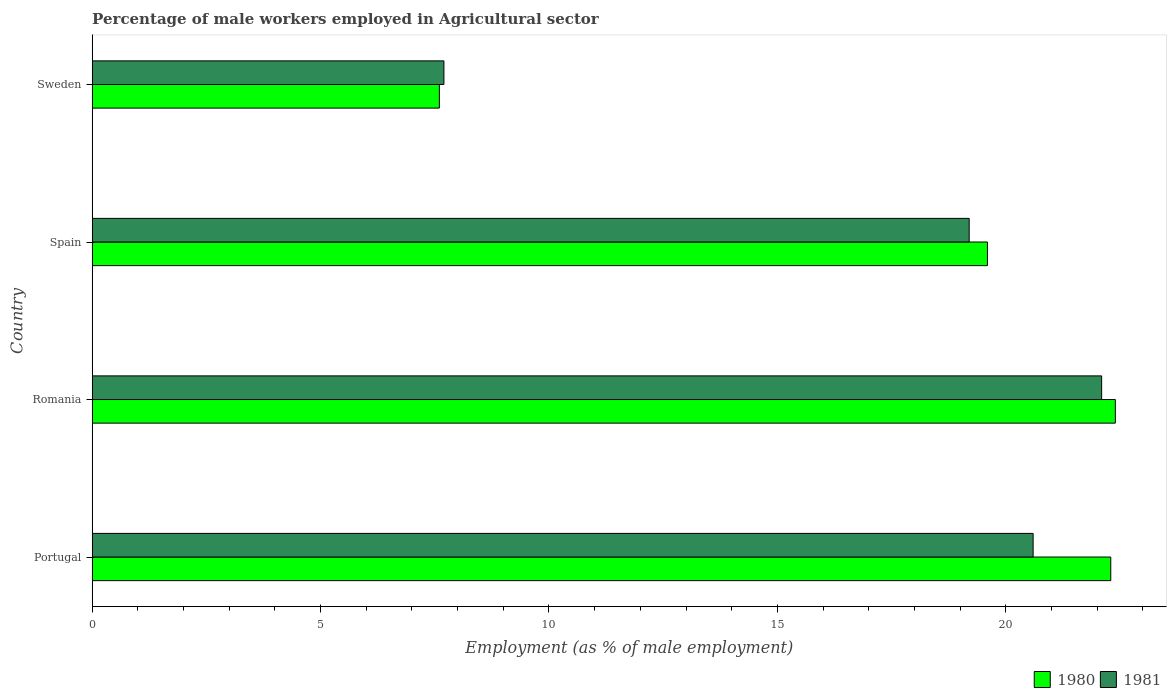How many different coloured bars are there?
Your answer should be very brief. 2. How many bars are there on the 2nd tick from the top?
Your response must be concise. 2. How many bars are there on the 3rd tick from the bottom?
Offer a very short reply. 2. What is the percentage of male workers employed in Agricultural sector in 1980 in Spain?
Your answer should be compact. 19.6. Across all countries, what is the maximum percentage of male workers employed in Agricultural sector in 1980?
Provide a succinct answer. 22.4. Across all countries, what is the minimum percentage of male workers employed in Agricultural sector in 1980?
Keep it short and to the point. 7.6. In which country was the percentage of male workers employed in Agricultural sector in 1980 maximum?
Provide a short and direct response. Romania. In which country was the percentage of male workers employed in Agricultural sector in 1981 minimum?
Make the answer very short. Sweden. What is the total percentage of male workers employed in Agricultural sector in 1981 in the graph?
Give a very brief answer. 69.6. What is the difference between the percentage of male workers employed in Agricultural sector in 1981 in Spain and that in Sweden?
Your response must be concise. 11.5. What is the average percentage of male workers employed in Agricultural sector in 1981 per country?
Give a very brief answer. 17.4. What is the difference between the percentage of male workers employed in Agricultural sector in 1981 and percentage of male workers employed in Agricultural sector in 1980 in Portugal?
Offer a very short reply. -1.7. What is the ratio of the percentage of male workers employed in Agricultural sector in 1981 in Portugal to that in Spain?
Your answer should be very brief. 1.07. Is the percentage of male workers employed in Agricultural sector in 1981 in Portugal less than that in Spain?
Provide a short and direct response. No. What is the difference between the highest and the second highest percentage of male workers employed in Agricultural sector in 1981?
Make the answer very short. 1.5. What is the difference between the highest and the lowest percentage of male workers employed in Agricultural sector in 1980?
Make the answer very short. 14.8. In how many countries, is the percentage of male workers employed in Agricultural sector in 1981 greater than the average percentage of male workers employed in Agricultural sector in 1981 taken over all countries?
Provide a short and direct response. 3. How many bars are there?
Offer a very short reply. 8. Are the values on the major ticks of X-axis written in scientific E-notation?
Provide a succinct answer. No. Does the graph contain grids?
Keep it short and to the point. No. How are the legend labels stacked?
Offer a terse response. Horizontal. What is the title of the graph?
Give a very brief answer. Percentage of male workers employed in Agricultural sector. What is the label or title of the X-axis?
Your response must be concise. Employment (as % of male employment). What is the Employment (as % of male employment) in 1980 in Portugal?
Offer a terse response. 22.3. What is the Employment (as % of male employment) of 1981 in Portugal?
Provide a short and direct response. 20.6. What is the Employment (as % of male employment) of 1980 in Romania?
Provide a short and direct response. 22.4. What is the Employment (as % of male employment) in 1981 in Romania?
Your answer should be very brief. 22.1. What is the Employment (as % of male employment) in 1980 in Spain?
Give a very brief answer. 19.6. What is the Employment (as % of male employment) of 1981 in Spain?
Your answer should be very brief. 19.2. What is the Employment (as % of male employment) in 1980 in Sweden?
Your answer should be compact. 7.6. What is the Employment (as % of male employment) in 1981 in Sweden?
Your response must be concise. 7.7. Across all countries, what is the maximum Employment (as % of male employment) of 1980?
Your response must be concise. 22.4. Across all countries, what is the maximum Employment (as % of male employment) of 1981?
Ensure brevity in your answer.  22.1. Across all countries, what is the minimum Employment (as % of male employment) in 1980?
Ensure brevity in your answer.  7.6. Across all countries, what is the minimum Employment (as % of male employment) of 1981?
Make the answer very short. 7.7. What is the total Employment (as % of male employment) of 1980 in the graph?
Offer a terse response. 71.9. What is the total Employment (as % of male employment) of 1981 in the graph?
Offer a very short reply. 69.6. What is the difference between the Employment (as % of male employment) of 1981 in Portugal and that in Romania?
Ensure brevity in your answer.  -1.5. What is the difference between the Employment (as % of male employment) of 1981 in Portugal and that in Sweden?
Ensure brevity in your answer.  12.9. What is the difference between the Employment (as % of male employment) in 1980 in Romania and that in Spain?
Offer a terse response. 2.8. What is the difference between the Employment (as % of male employment) in 1981 in Romania and that in Spain?
Give a very brief answer. 2.9. What is the difference between the Employment (as % of male employment) of 1980 in Romania and that in Sweden?
Keep it short and to the point. 14.8. What is the difference between the Employment (as % of male employment) in 1981 in Spain and that in Sweden?
Provide a succinct answer. 11.5. What is the difference between the Employment (as % of male employment) in 1980 in Spain and the Employment (as % of male employment) in 1981 in Sweden?
Provide a succinct answer. 11.9. What is the average Employment (as % of male employment) in 1980 per country?
Provide a short and direct response. 17.98. What is the difference between the Employment (as % of male employment) of 1980 and Employment (as % of male employment) of 1981 in Portugal?
Ensure brevity in your answer.  1.7. What is the difference between the Employment (as % of male employment) in 1980 and Employment (as % of male employment) in 1981 in Romania?
Your response must be concise. 0.3. What is the difference between the Employment (as % of male employment) in 1980 and Employment (as % of male employment) in 1981 in Spain?
Your answer should be very brief. 0.4. What is the difference between the Employment (as % of male employment) of 1980 and Employment (as % of male employment) of 1981 in Sweden?
Your answer should be very brief. -0.1. What is the ratio of the Employment (as % of male employment) in 1981 in Portugal to that in Romania?
Your answer should be compact. 0.93. What is the ratio of the Employment (as % of male employment) of 1980 in Portugal to that in Spain?
Make the answer very short. 1.14. What is the ratio of the Employment (as % of male employment) in 1981 in Portugal to that in Spain?
Keep it short and to the point. 1.07. What is the ratio of the Employment (as % of male employment) of 1980 in Portugal to that in Sweden?
Your response must be concise. 2.93. What is the ratio of the Employment (as % of male employment) of 1981 in Portugal to that in Sweden?
Provide a short and direct response. 2.68. What is the ratio of the Employment (as % of male employment) in 1981 in Romania to that in Spain?
Give a very brief answer. 1.15. What is the ratio of the Employment (as % of male employment) in 1980 in Romania to that in Sweden?
Provide a succinct answer. 2.95. What is the ratio of the Employment (as % of male employment) in 1981 in Romania to that in Sweden?
Keep it short and to the point. 2.87. What is the ratio of the Employment (as % of male employment) in 1980 in Spain to that in Sweden?
Ensure brevity in your answer.  2.58. What is the ratio of the Employment (as % of male employment) of 1981 in Spain to that in Sweden?
Keep it short and to the point. 2.49. What is the difference between the highest and the lowest Employment (as % of male employment) of 1980?
Your answer should be compact. 14.8. 